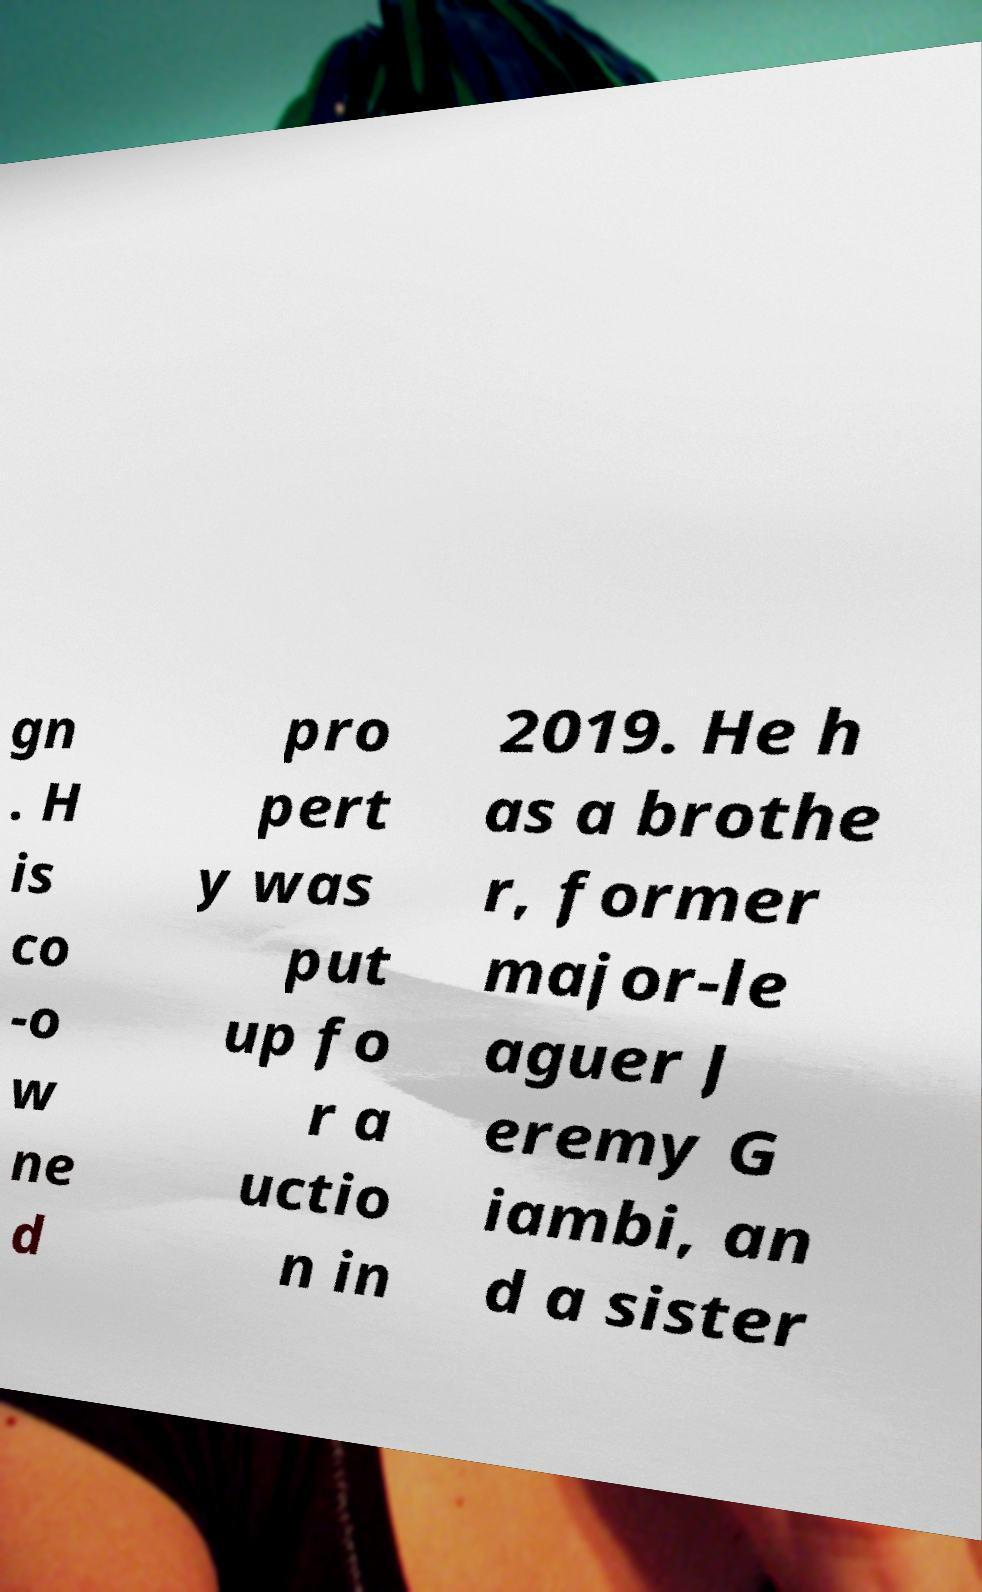Could you extract and type out the text from this image? gn . H is co -o w ne d pro pert y was put up fo r a uctio n in 2019. He h as a brothe r, former major-le aguer J eremy G iambi, an d a sister 